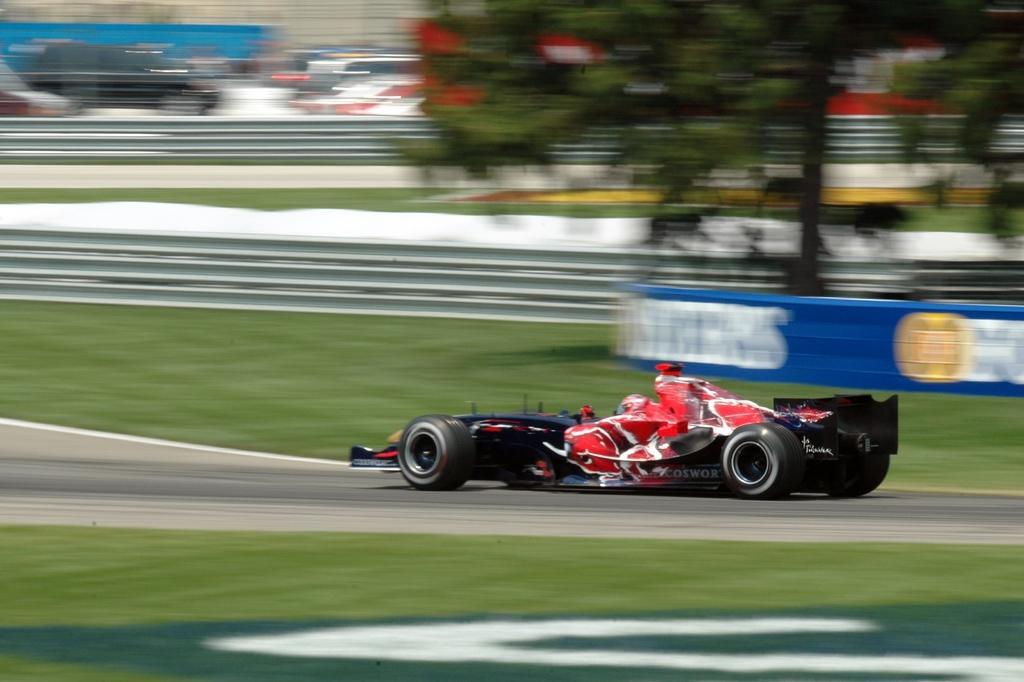Can you describe this image briefly? In the center of the image, we can see a vehicle on the road and in the background, there are trees, fences, boards and we can see some vehicles. 